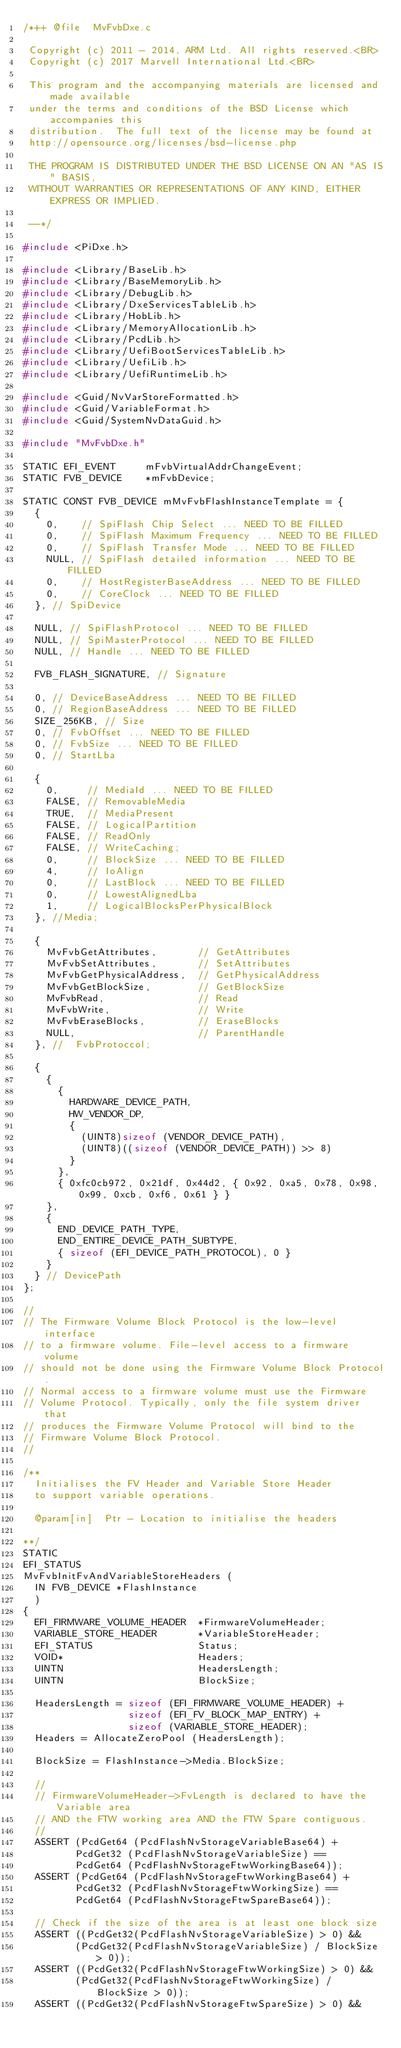Convert code to text. <code><loc_0><loc_0><loc_500><loc_500><_C_>/*++ @file  MvFvbDxe.c

 Copyright (c) 2011 - 2014, ARM Ltd. All rights reserved.<BR>
 Copyright (c) 2017 Marvell International Ltd.<BR>

 This program and the accompanying materials are licensed and made available
 under the terms and conditions of the BSD License which accompanies this
 distribution.  The full text of the license may be found at
 http://opensource.org/licenses/bsd-license.php

 THE PROGRAM IS DISTRIBUTED UNDER THE BSD LICENSE ON AN "AS IS" BASIS,
 WITHOUT WARRANTIES OR REPRESENTATIONS OF ANY KIND, EITHER EXPRESS OR IMPLIED.

 --*/

#include <PiDxe.h>

#include <Library/BaseLib.h>
#include <Library/BaseMemoryLib.h>
#include <Library/DebugLib.h>
#include <Library/DxeServicesTableLib.h>
#include <Library/HobLib.h>
#include <Library/MemoryAllocationLib.h>
#include <Library/PcdLib.h>
#include <Library/UefiBootServicesTableLib.h>
#include <Library/UefiLib.h>
#include <Library/UefiRuntimeLib.h>

#include <Guid/NvVarStoreFormatted.h>
#include <Guid/VariableFormat.h>
#include <Guid/SystemNvDataGuid.h>

#include "MvFvbDxe.h"

STATIC EFI_EVENT     mFvbVirtualAddrChangeEvent;
STATIC FVB_DEVICE    *mFvbDevice;

STATIC CONST FVB_DEVICE mMvFvbFlashInstanceTemplate = {
  {
    0,    // SpiFlash Chip Select ... NEED TO BE FILLED
    0,    // SpiFlash Maximum Frequency ... NEED TO BE FILLED
    0,    // SpiFlash Transfer Mode ... NEED TO BE FILLED
    NULL, // SpiFlash detailed information ... NEED TO BE FILLED
    0,    // HostRegisterBaseAddress ... NEED TO BE FILLED
    0,    // CoreClock ... NEED TO BE FILLED
  }, // SpiDevice

  NULL, // SpiFlashProtocol ... NEED TO BE FILLED
  NULL, // SpiMasterProtocol ... NEED TO BE FILLED
  NULL, // Handle ... NEED TO BE FILLED

  FVB_FLASH_SIGNATURE, // Signature

  0, // DeviceBaseAddress ... NEED TO BE FILLED
  0, // RegionBaseAddress ... NEED TO BE FILLED
  SIZE_256KB, // Size
  0, // FvbOffset ... NEED TO BE FILLED
  0, // FvbSize ... NEED TO BE FILLED
  0, // StartLba

  {
    0,     // MediaId ... NEED TO BE FILLED
    FALSE, // RemovableMedia
    TRUE,  // MediaPresent
    FALSE, // LogicalPartition
    FALSE, // ReadOnly
    FALSE, // WriteCaching;
    0,     // BlockSize ... NEED TO BE FILLED
    4,     // IoAlign
    0,     // LastBlock ... NEED TO BE FILLED
    0,     // LowestAlignedLba
    1,     // LogicalBlocksPerPhysicalBlock
  }, //Media;

  {
    MvFvbGetAttributes,       // GetAttributes
    MvFvbSetAttributes,       // SetAttributes
    MvFvbGetPhysicalAddress,  // GetPhysicalAddress
    MvFvbGetBlockSize,        // GetBlockSize
    MvFvbRead,                // Read
    MvFvbWrite,               // Write
    MvFvbEraseBlocks,         // EraseBlocks
    NULL,                     // ParentHandle
  }, //  FvbProtoccol;

  {
    {
      {
        HARDWARE_DEVICE_PATH,
        HW_VENDOR_DP,
        {
          (UINT8)sizeof (VENDOR_DEVICE_PATH),
          (UINT8)((sizeof (VENDOR_DEVICE_PATH)) >> 8)
        }
      },
      { 0xfc0cb972, 0x21df, 0x44d2, { 0x92, 0xa5, 0x78, 0x98, 0x99, 0xcb, 0xf6, 0x61 } }
    },
    {
      END_DEVICE_PATH_TYPE,
      END_ENTIRE_DEVICE_PATH_SUBTYPE,
      { sizeof (EFI_DEVICE_PATH_PROTOCOL), 0 }
    }
  } // DevicePath
};

//
// The Firmware Volume Block Protocol is the low-level interface
// to a firmware volume. File-level access to a firmware volume
// should not be done using the Firmware Volume Block Protocol.
// Normal access to a firmware volume must use the Firmware
// Volume Protocol. Typically, only the file system driver that
// produces the Firmware Volume Protocol will bind to the
// Firmware Volume Block Protocol.
//

/**
  Initialises the FV Header and Variable Store Header
  to support variable operations.

  @param[in]  Ptr - Location to initialise the headers

**/
STATIC
EFI_STATUS
MvFvbInitFvAndVariableStoreHeaders (
  IN FVB_DEVICE *FlashInstance
  )
{
  EFI_FIRMWARE_VOLUME_HEADER  *FirmwareVolumeHeader;
  VARIABLE_STORE_HEADER       *VariableStoreHeader;
  EFI_STATUS                  Status;
  VOID*                       Headers;
  UINTN                       HeadersLength;
  UINTN                       BlockSize;

  HeadersLength = sizeof (EFI_FIRMWARE_VOLUME_HEADER) +
                  sizeof (EFI_FV_BLOCK_MAP_ENTRY) +
                  sizeof (VARIABLE_STORE_HEADER);
  Headers = AllocateZeroPool (HeadersLength);

  BlockSize = FlashInstance->Media.BlockSize;

  //
  // FirmwareVolumeHeader->FvLength is declared to have the Variable area
  // AND the FTW working area AND the FTW Spare contiguous.
  //
  ASSERT (PcdGet64 (PcdFlashNvStorageVariableBase64) +
         PcdGet32 (PcdFlashNvStorageVariableSize) ==
         PcdGet64 (PcdFlashNvStorageFtwWorkingBase64));
  ASSERT (PcdGet64 (PcdFlashNvStorageFtwWorkingBase64) +
         PcdGet32 (PcdFlashNvStorageFtwWorkingSize) ==
         PcdGet64 (PcdFlashNvStorageFtwSpareBase64));

  // Check if the size of the area is at least one block size
  ASSERT ((PcdGet32(PcdFlashNvStorageVariableSize) > 0) &&
         (PcdGet32(PcdFlashNvStorageVariableSize) / BlockSize > 0));
  ASSERT ((PcdGet32(PcdFlashNvStorageFtwWorkingSize) > 0) &&
         (PcdGet32(PcdFlashNvStorageFtwWorkingSize) / BlockSize > 0));
  ASSERT ((PcdGet32(PcdFlashNvStorageFtwSpareSize) > 0) &&</code> 